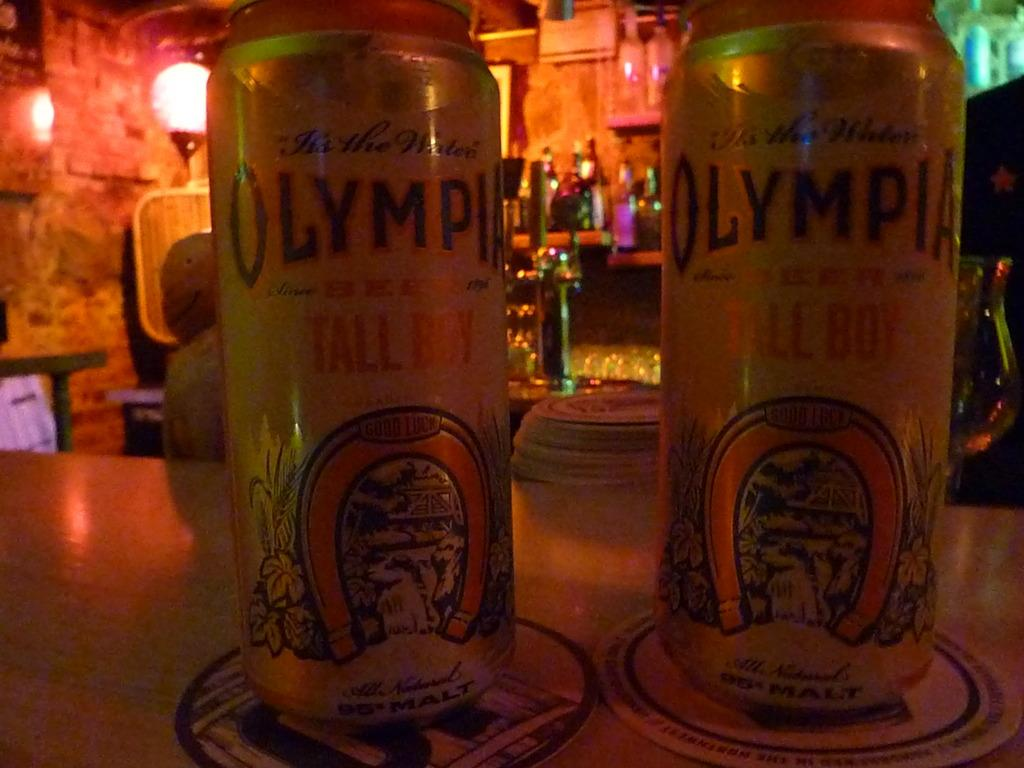<image>
Write a terse but informative summary of the picture. two cans next to one another labeled 'olympia' 